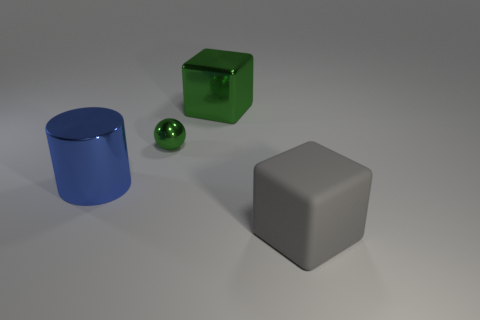Add 4 small red metallic cylinders. How many objects exist? 8 Add 1 big blue metal cylinders. How many big blue metal cylinders exist? 2 Subtract 0 brown spheres. How many objects are left? 4 Subtract all big green blocks. Subtract all blocks. How many objects are left? 1 Add 1 blue metal objects. How many blue metal objects are left? 2 